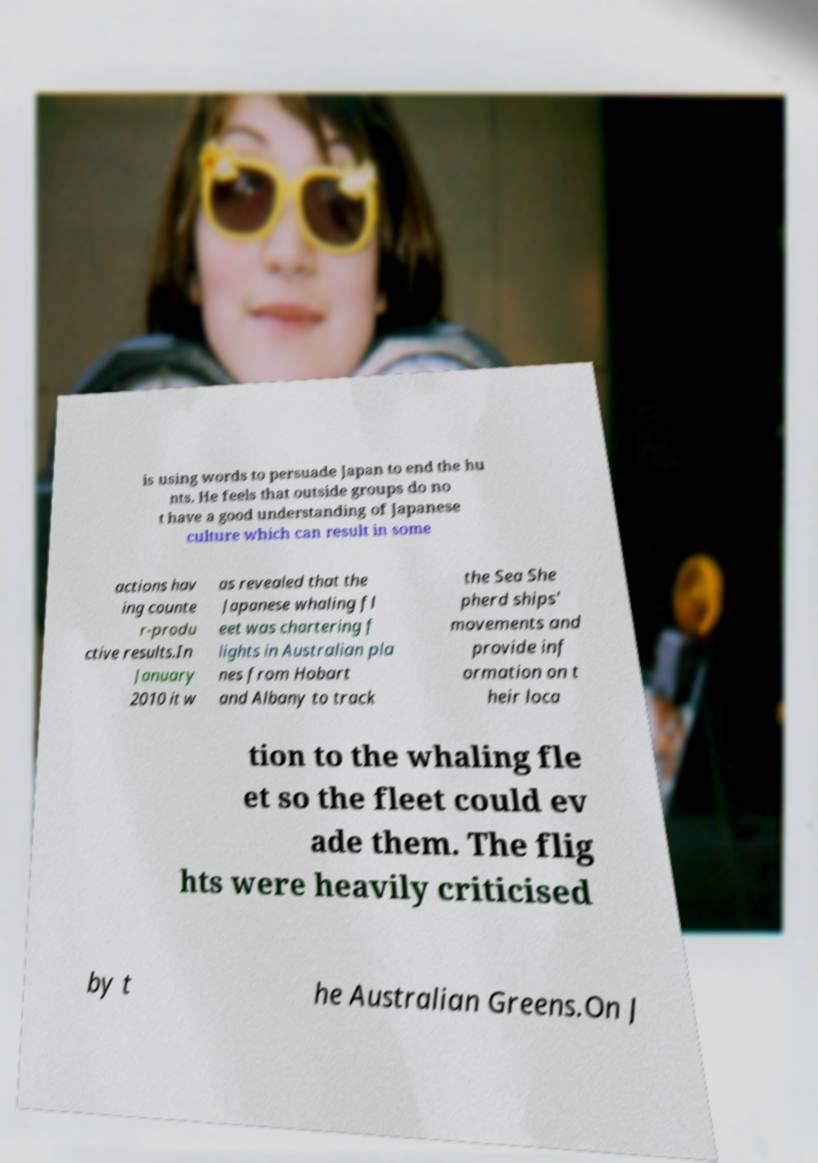Could you extract and type out the text from this image? is using words to persuade Japan to end the hu nts. He feels that outside groups do no t have a good understanding of Japanese culture which can result in some actions hav ing counte r-produ ctive results.In January 2010 it w as revealed that the Japanese whaling fl eet was chartering f lights in Australian pla nes from Hobart and Albany to track the Sea She pherd ships' movements and provide inf ormation on t heir loca tion to the whaling fle et so the fleet could ev ade them. The flig hts were heavily criticised by t he Australian Greens.On J 